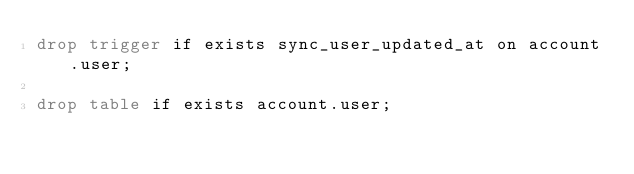Convert code to text. <code><loc_0><loc_0><loc_500><loc_500><_SQL_>drop trigger if exists sync_user_updated_at on account.user;

drop table if exists account.user;
</code> 